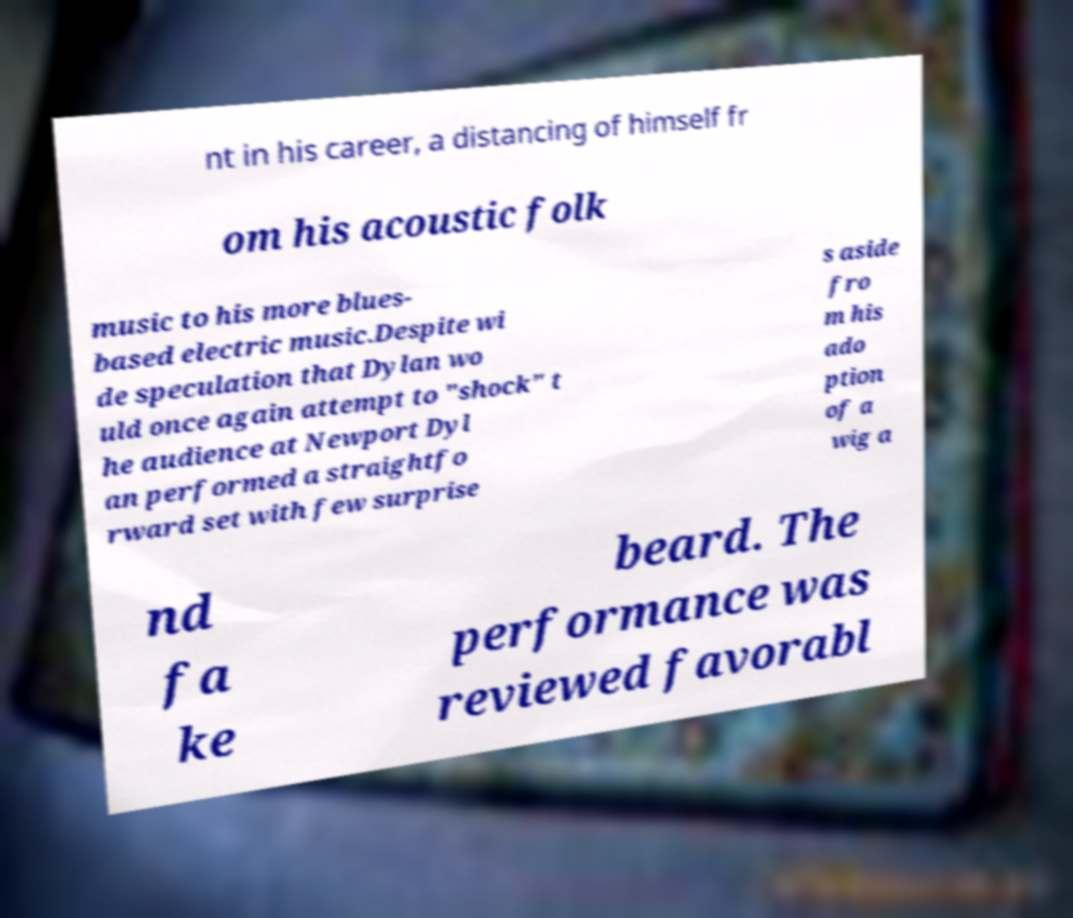Could you extract and type out the text from this image? nt in his career, a distancing of himself fr om his acoustic folk music to his more blues- based electric music.Despite wi de speculation that Dylan wo uld once again attempt to "shock" t he audience at Newport Dyl an performed a straightfo rward set with few surprise s aside fro m his ado ption of a wig a nd fa ke beard. The performance was reviewed favorabl 